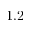Convert formula to latex. <formula><loc_0><loc_0><loc_500><loc_500>1 . 2</formula> 